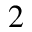Convert formula to latex. <formula><loc_0><loc_0><loc_500><loc_500>^ { 2 }</formula> 